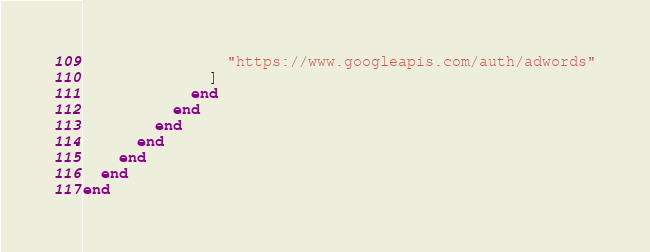Convert code to text. <code><loc_0><loc_0><loc_500><loc_500><_Ruby_>                "https://www.googleapis.com/auth/adwords"
              ]
            end
          end
        end
      end
    end
  end
end
</code> 